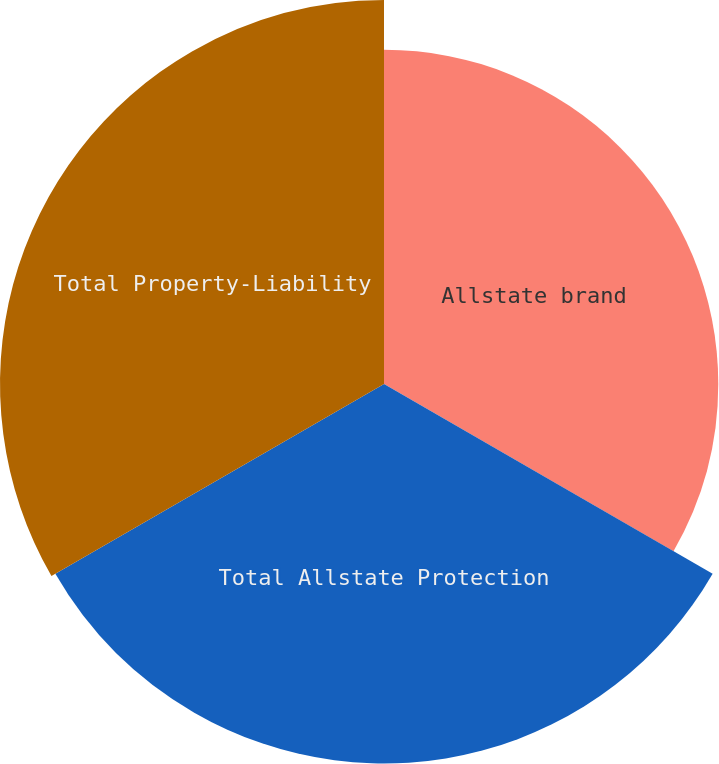Convert chart to OTSL. <chart><loc_0><loc_0><loc_500><loc_500><pie_chart><fcel>Allstate brand<fcel>Total Allstate Protection<fcel>Total Property-Liability<nl><fcel>30.45%<fcel>34.57%<fcel>34.98%<nl></chart> 